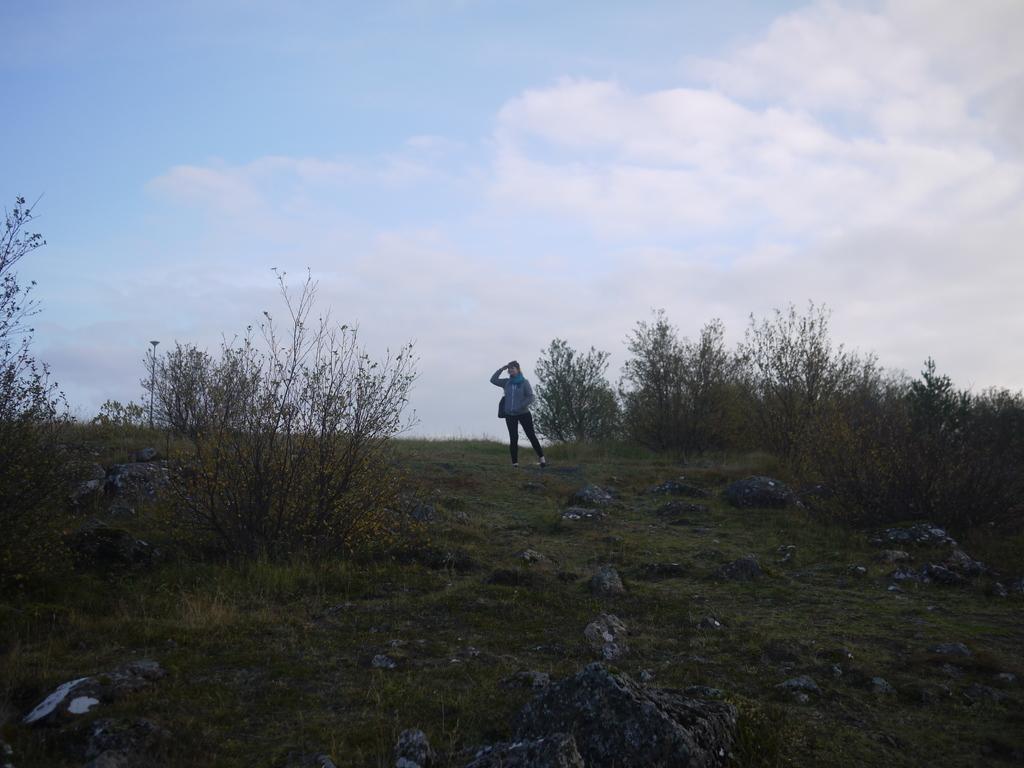Can you describe this image briefly? This is a person standing. These are the trees. I can see the rocks and the grass. I think this looks like a small hill. Here is the sky. 